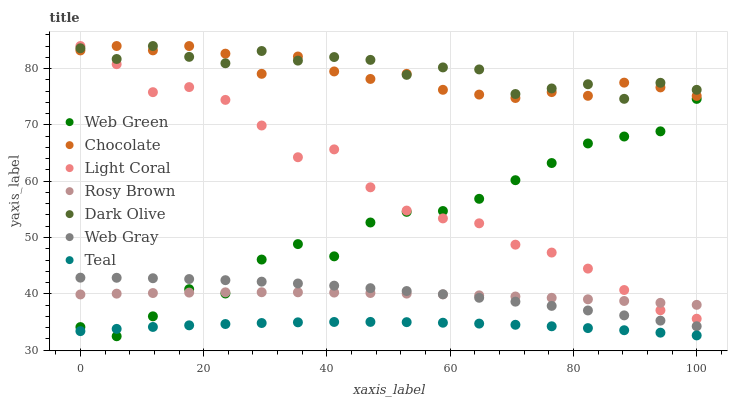Does Teal have the minimum area under the curve?
Answer yes or no. Yes. Does Dark Olive have the maximum area under the curve?
Answer yes or no. Yes. Does Rosy Brown have the minimum area under the curve?
Answer yes or no. No. Does Rosy Brown have the maximum area under the curve?
Answer yes or no. No. Is Rosy Brown the smoothest?
Answer yes or no. Yes. Is Web Green the roughest?
Answer yes or no. Yes. Is Dark Olive the smoothest?
Answer yes or no. No. Is Dark Olive the roughest?
Answer yes or no. No. Does Web Green have the lowest value?
Answer yes or no. Yes. Does Dark Olive have the lowest value?
Answer yes or no. No. Does Chocolate have the highest value?
Answer yes or no. Yes. Does Rosy Brown have the highest value?
Answer yes or no. No. Is Teal less than Rosy Brown?
Answer yes or no. Yes. Is Dark Olive greater than Teal?
Answer yes or no. Yes. Does Rosy Brown intersect Web Gray?
Answer yes or no. Yes. Is Rosy Brown less than Web Gray?
Answer yes or no. No. Is Rosy Brown greater than Web Gray?
Answer yes or no. No. Does Teal intersect Rosy Brown?
Answer yes or no. No. 